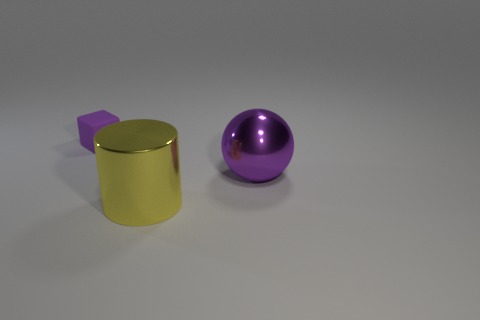Add 2 large shiny spheres. How many objects exist? 5 Subtract all gray balls. Subtract all purple cubes. How many balls are left? 1 Subtract all cubes. How many objects are left? 2 Add 2 small purple things. How many small purple things are left? 3 Add 2 big red metallic blocks. How many big red metallic blocks exist? 2 Subtract 0 gray spheres. How many objects are left? 3 Subtract all big purple things. Subtract all tiny gray objects. How many objects are left? 2 